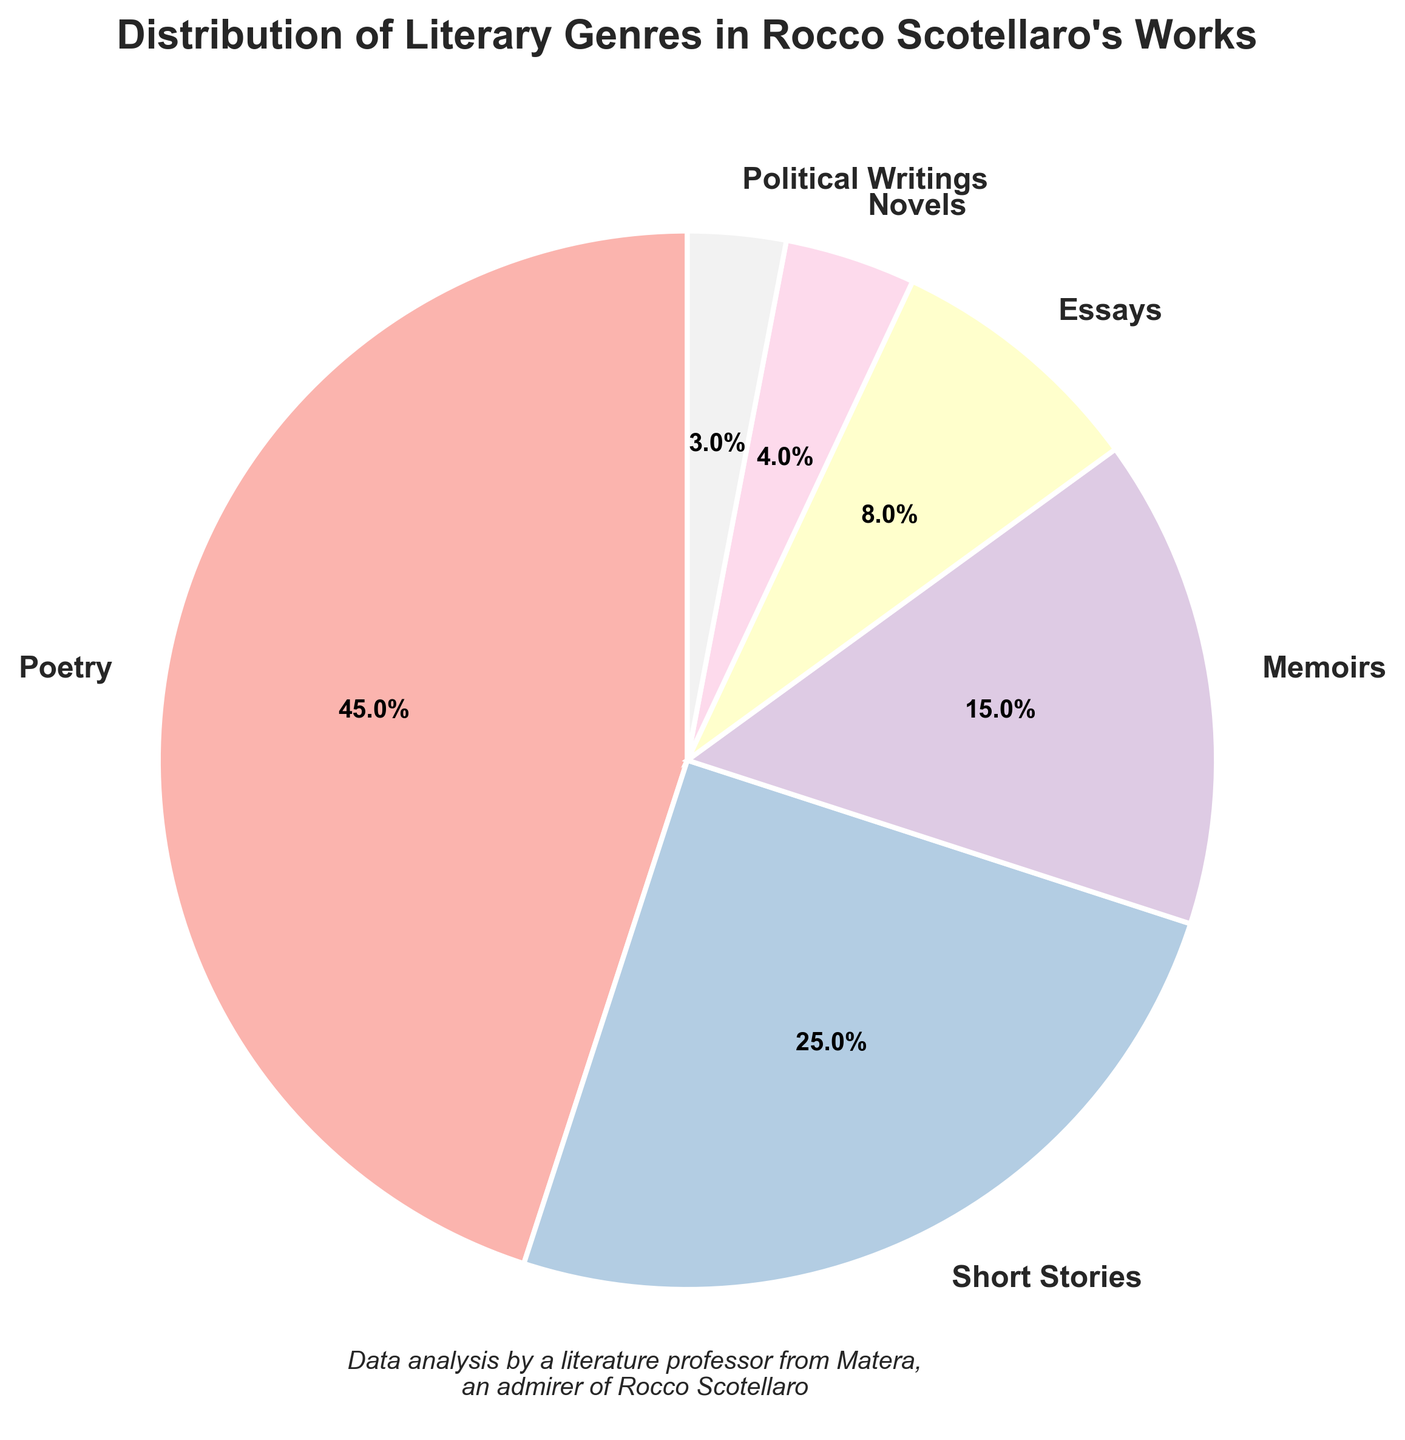Which literary genre has the highest percentage in Rocco Scotellaro's works? Refer to the slices in the pie chart and look for the largest one, which is also labeled.
Answer: Poetry What is the total percentage of Short Stories and Memoirs combined? Sum the percentages for Short Stories (25%) and Memoirs (15%). 25% + 15% = 40%
Answer: 40% How do the percentages of Novels and Political Writings compare? Look at the slices for Novels and Political Writings. Novels have 4% and Political Writings have 3%. 4% is greater than 3%.
Answer: Novels have a higher percentage than Political Writings Which genre occupies the least percentage in the pie chart, and what is its value? Identify the smallest slice in the chart, which is labeled with its percentage. Political Writings have the smallest slice with 3%.
Answer: Political Writings, 3% What is the difference in percentage between the genres with the highest and lowest representation? Poetry (45%) is the highest and Political Writings (3%) is the lowest. Subtract the smallest percentage from the largest: 45% - 3% = 42%.
Answer: 42% How many genres have a percentage of 10% or higher? Count the number of slices with percentages 10% or higher: Poetry (45%), Short Stories (25%), and Memoirs (15%). There are three such genres.
Answer: 3 Combine the percentages of Essays and Novels. Is it higher or lower than the percentage of Short Stories? Add the percentages of Essays (8%) and Novels (4%): 8% + 4% = 12%. Compare it to Short Stories (25%). 12% is less than 25%.
Answer: Lower What color is used to represent the genre with 8% in the pie chart? Identify the slice labeled with 8% (Essays) and check its color.
Answer: Pastel1 color used for Essays (visual inspection needed) Which two genres combined make up exactly 30% of the pie chart? Find combinations of slices that add up to 30%. Short Stories (25%) + Political Writings (3%) + Novels (2%) and Essays (8%) = no valid combination.
Answer: No valid combination What is the average percentage of the genres with percentages less than 10%? Identify and sum the percentages: Essays (8%), Novels (4%), and Political Writings (3%). (8% + 4% + 3%) = 15% and divide by 3 genres: 15% / 3 = 5%.
Answer: 5% 